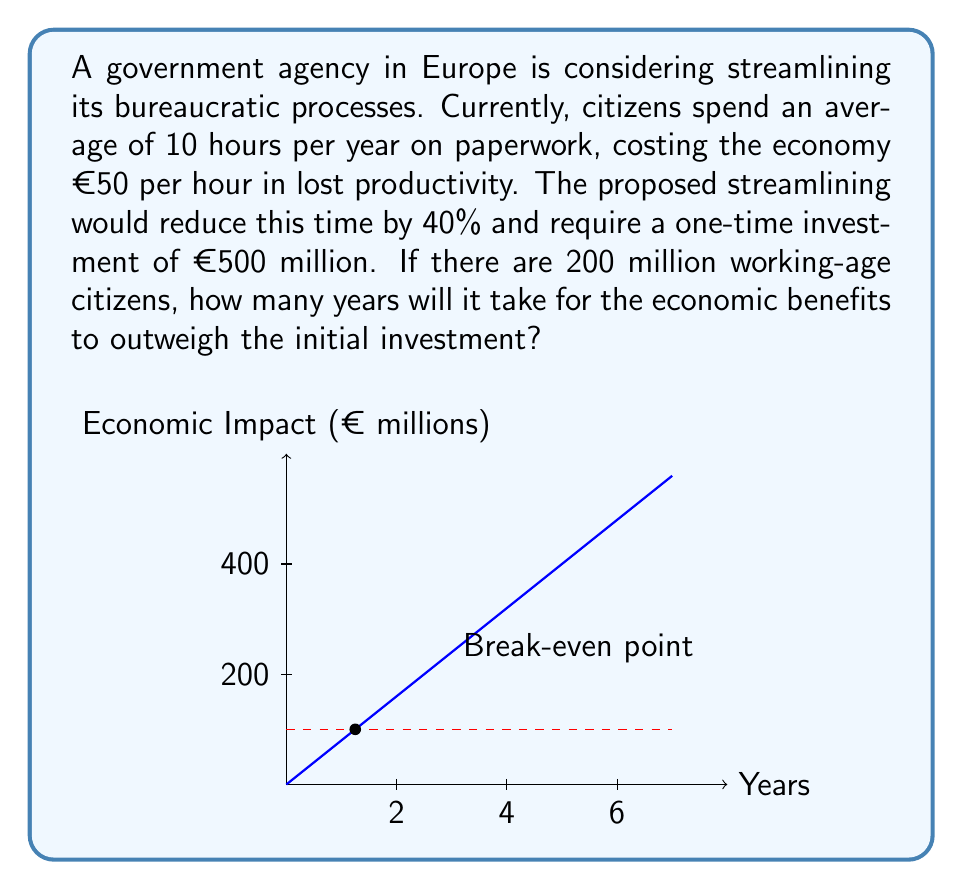Can you solve this math problem? Let's approach this step-by-step:

1) First, calculate the current annual cost of bureaucracy:
   $$\text{Annual Cost} = 200\text{ million} \times 10\text{ hours} \times €50/\text{hour} = €100\text{ billion}$$

2) Calculate the savings from streamlining:
   $$\text{Savings} = 40\% \times €100\text{ billion} = €40\text{ billion per year}$$

3) Convert the savings to millions for consistency with the investment:
   $$\text{Savings in millions} = €40,000\text{ million per year}$$

4) Set up an equation where the cumulative savings equal the investment:
   $$40,000x = 500$$
   Where $x$ is the number of years.

5) Solve for $x$:
   $$x = \frac{500}{40,000} = 0.0125\text{ years}$$

6) Convert to days:
   $$0.0125 \times 365 = 4.5625\text{ days}$$

The break-even point occurs just after 4.5 days, which is much less than a year.
Answer: 4.5625 days 